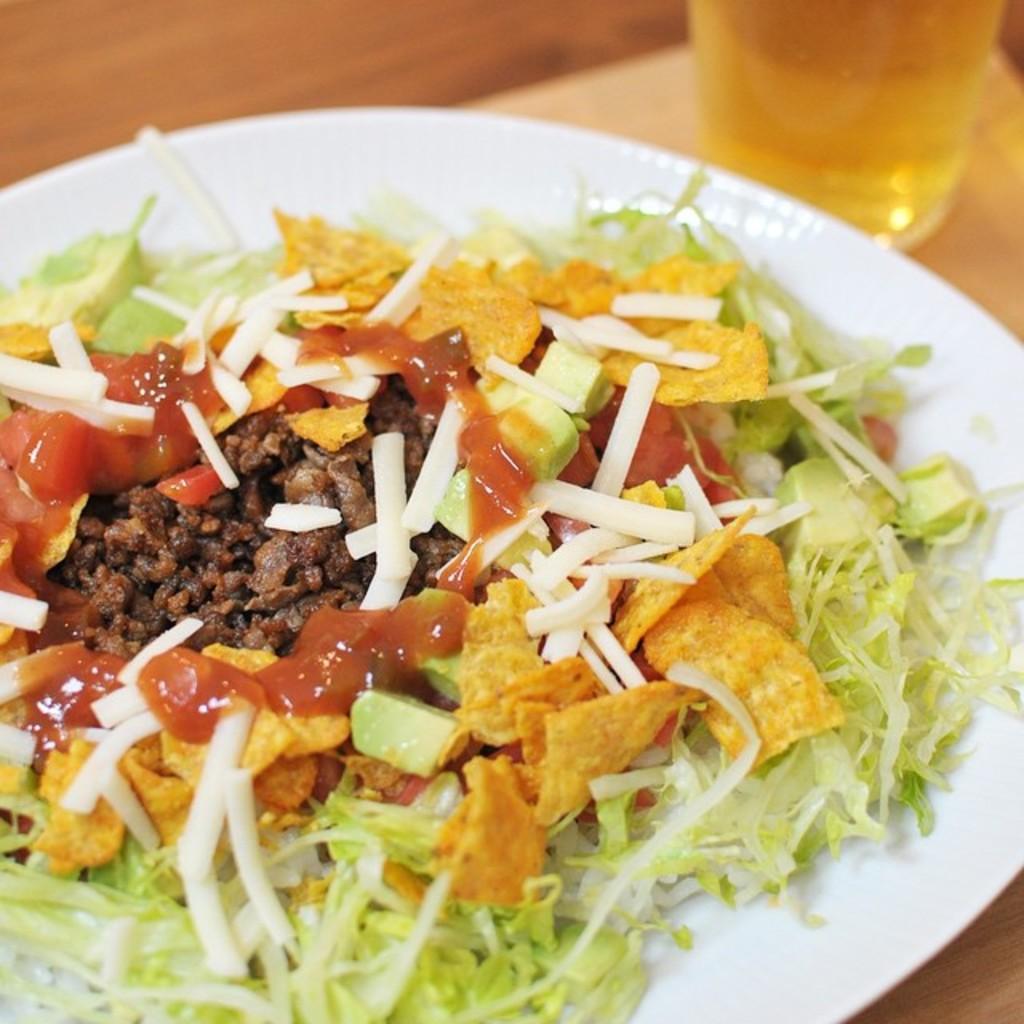Please provide a concise description of this image. In the center of the image there is a table. On the table we can see a plate which contains food item and a glass which contains liquid. 